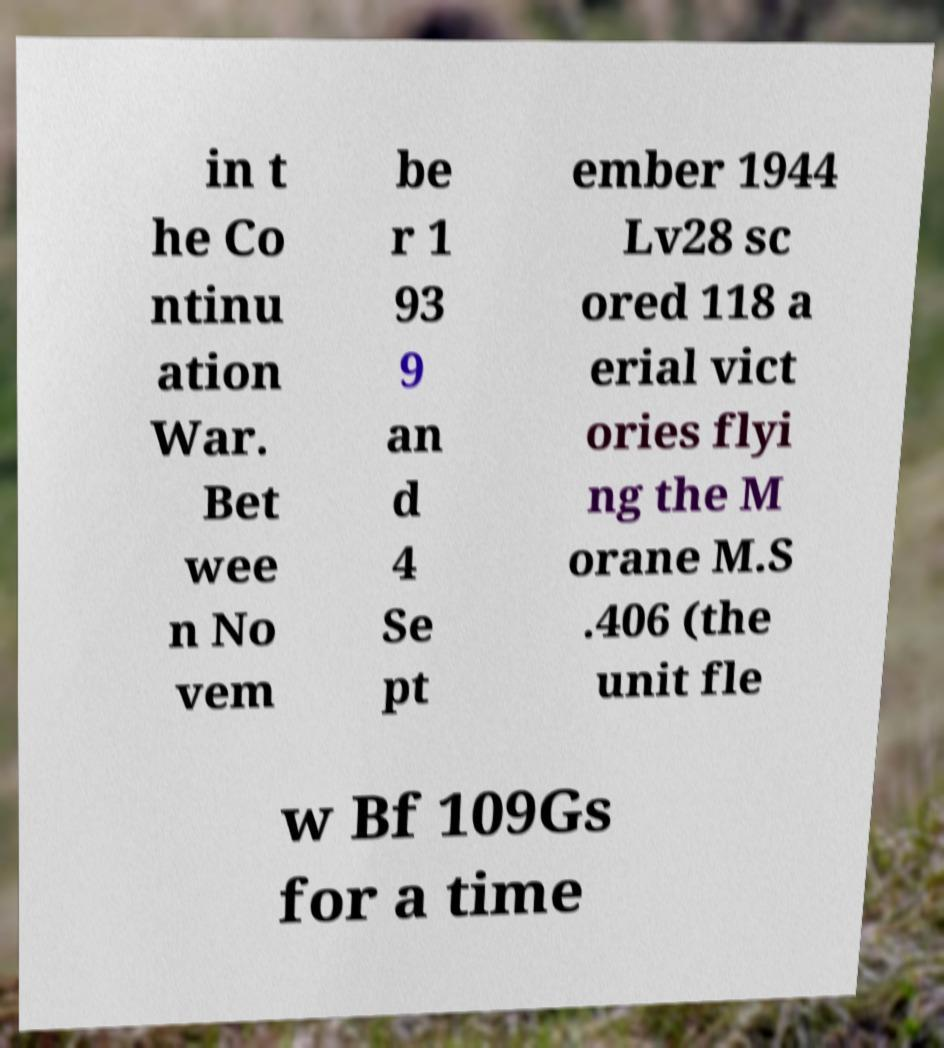What messages or text are displayed in this image? I need them in a readable, typed format. in t he Co ntinu ation War. Bet wee n No vem be r 1 93 9 an d 4 Se pt ember 1944 Lv28 sc ored 118 a erial vict ories flyi ng the M orane M.S .406 (the unit fle w Bf 109Gs for a time 